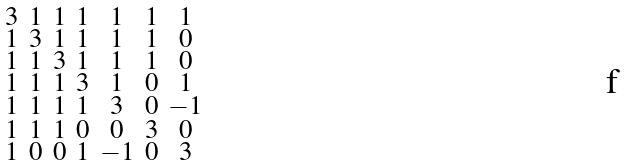Convert formula to latex. <formula><loc_0><loc_0><loc_500><loc_500>\begin{smallmatrix} 3 & 1 & 1 & 1 & 1 & 1 & 1 \\ 1 & 3 & 1 & 1 & 1 & 1 & 0 \\ 1 & 1 & 3 & 1 & 1 & 1 & 0 \\ 1 & 1 & 1 & 3 & 1 & 0 & 1 \\ 1 & 1 & 1 & 1 & 3 & 0 & - 1 \\ 1 & 1 & 1 & 0 & 0 & 3 & 0 \\ 1 & 0 & 0 & 1 & - 1 & 0 & 3 \end{smallmatrix}</formula> 